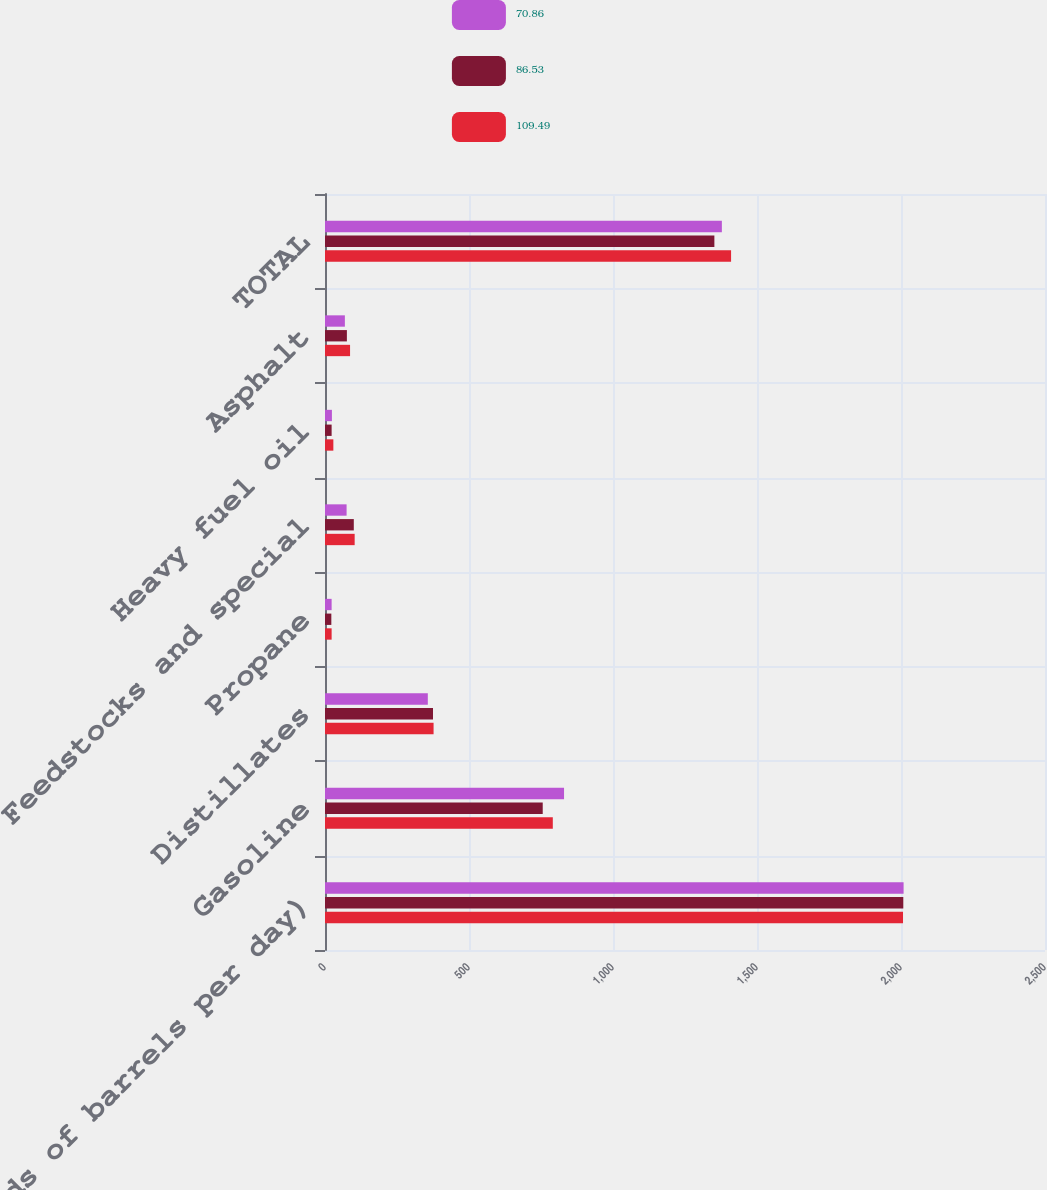<chart> <loc_0><loc_0><loc_500><loc_500><stacked_bar_chart><ecel><fcel>(Thousands of barrels per day)<fcel>Gasoline<fcel>Distillates<fcel>Propane<fcel>Feedstocks and special<fcel>Heavy fuel oil<fcel>Asphalt<fcel>TOTAL<nl><fcel>70.86<fcel>2009<fcel>830<fcel>357<fcel>23<fcel>75<fcel>24<fcel>69<fcel>1378<nl><fcel>86.53<fcel>2008<fcel>756<fcel>375<fcel>22<fcel>100<fcel>23<fcel>76<fcel>1352<nl><fcel>109.49<fcel>2007<fcel>791<fcel>377<fcel>23<fcel>103<fcel>29<fcel>87<fcel>1410<nl></chart> 